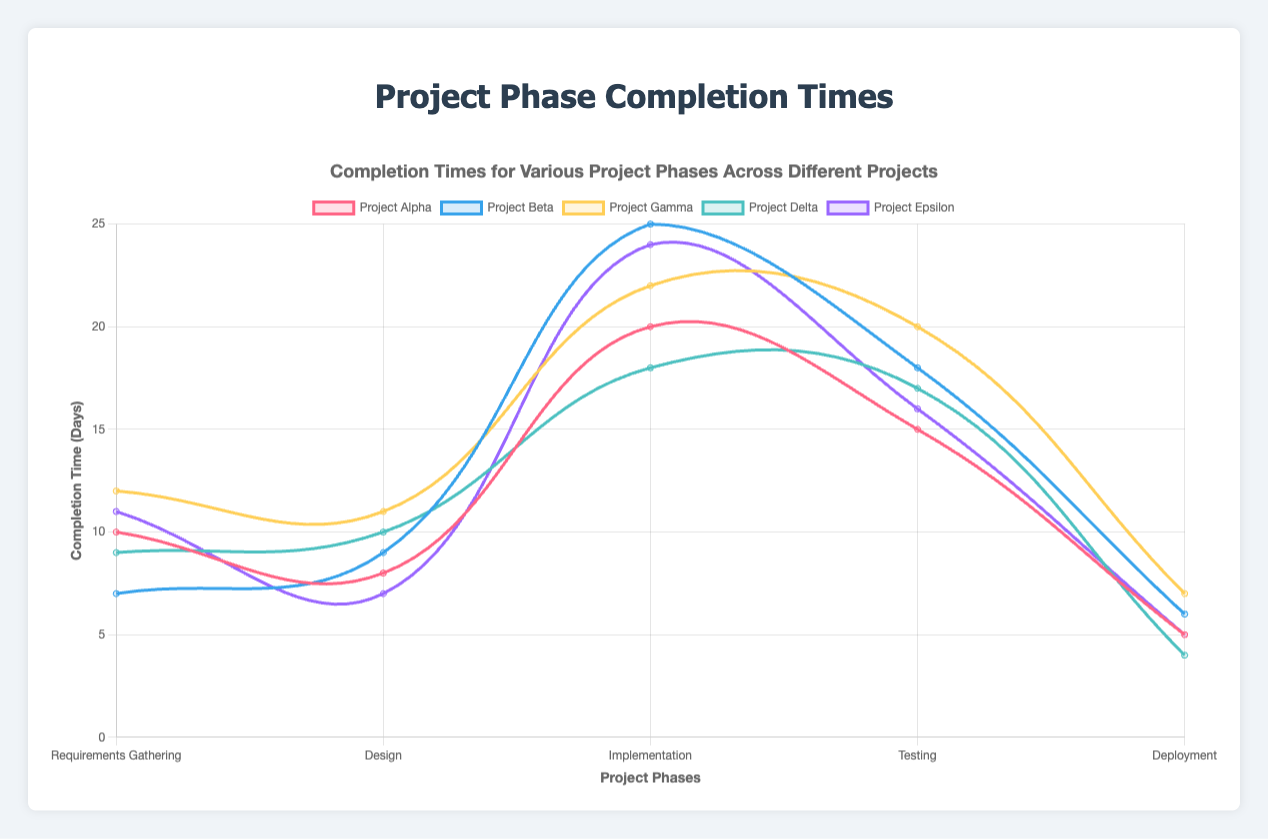Which project phase had the shortest completion time in Project Delta? Look at the line representing Project Delta and find the lowest point along the y-axis, which represents the shortest completion time for Project Delta. The Deployment phase took 4 days, which is the shortest.
Answer: Deployment Which project had the longest completion time for the Implementation phase? Examine the line segments corresponding to the Implementation phase across all projects, then identify which project’s line reaches the highest point on the y-axis. Project Beta has the highest point at 25 days.
Answer: Project Beta What is the total completion time for Project Alpha? Sum the completion times of all phases for Project Alpha: 10 (Requirements Gathering) + 8 (Design) + 20 (Implementation) + 15 (Testing) + 5 (Deployment). The total is 58 days.
Answer: 58 days Which projects have the same completion time for the Deployment phase? Identify the points corresponding to the Deployment phase for each project and compare their y-axis values. Both Project Alpha and Project Epsilon have a Deployment time of 5 days.
Answer: Project Alpha and Project Epsilon What is the difference in completion times for the Testing phase between Project Gamma and Project Delta? Find and compare the y-axis values for the Testing phase in both Project Gamma and Project Delta. Project Gamma took 20 days and Project Delta took 17 days, so the difference is 20 - 17 = 3 days.
Answer: 3 days Which project had the most consistent completion times across all phases? Look at the overall shape of the lines for each project to see which one is the flattest, indicating less variation in completion times. Project Delta has the most consistent times as its line is relatively flat compared to others.
Answer: Project Delta What is the average completion time for the Design phase across all projects? Add the Design completion times for all projects and divide by the number of projects: (8 + 9 + 11 + 10 + 7) / 5. The average is (45 / 5) = 9 days.
Answer: 9 days How much longer did Project Alpha take for Implementation compared to Project Delta? Compare the y-axis values for Implementation in both projects. Project Alpha took 20 days, Project Delta took 18 days. The difference is 20 - 18 = 2 days.
Answer: 2 days Which phase generally took the longest to complete across all projects? Compare the general patterns of all phases across the different lines to identify which phase has the highest y-axis values on average. The Implementation phase consistently has higher values.
Answer: Implementation What is the median completion time for the Deployment phase across all projects? List the Deployment times: 5, 4, 7, 5, 6 and find the middle value. When sorted (4, 5, 5, 6, 7), the middle value is 5.
Answer: 5 days 